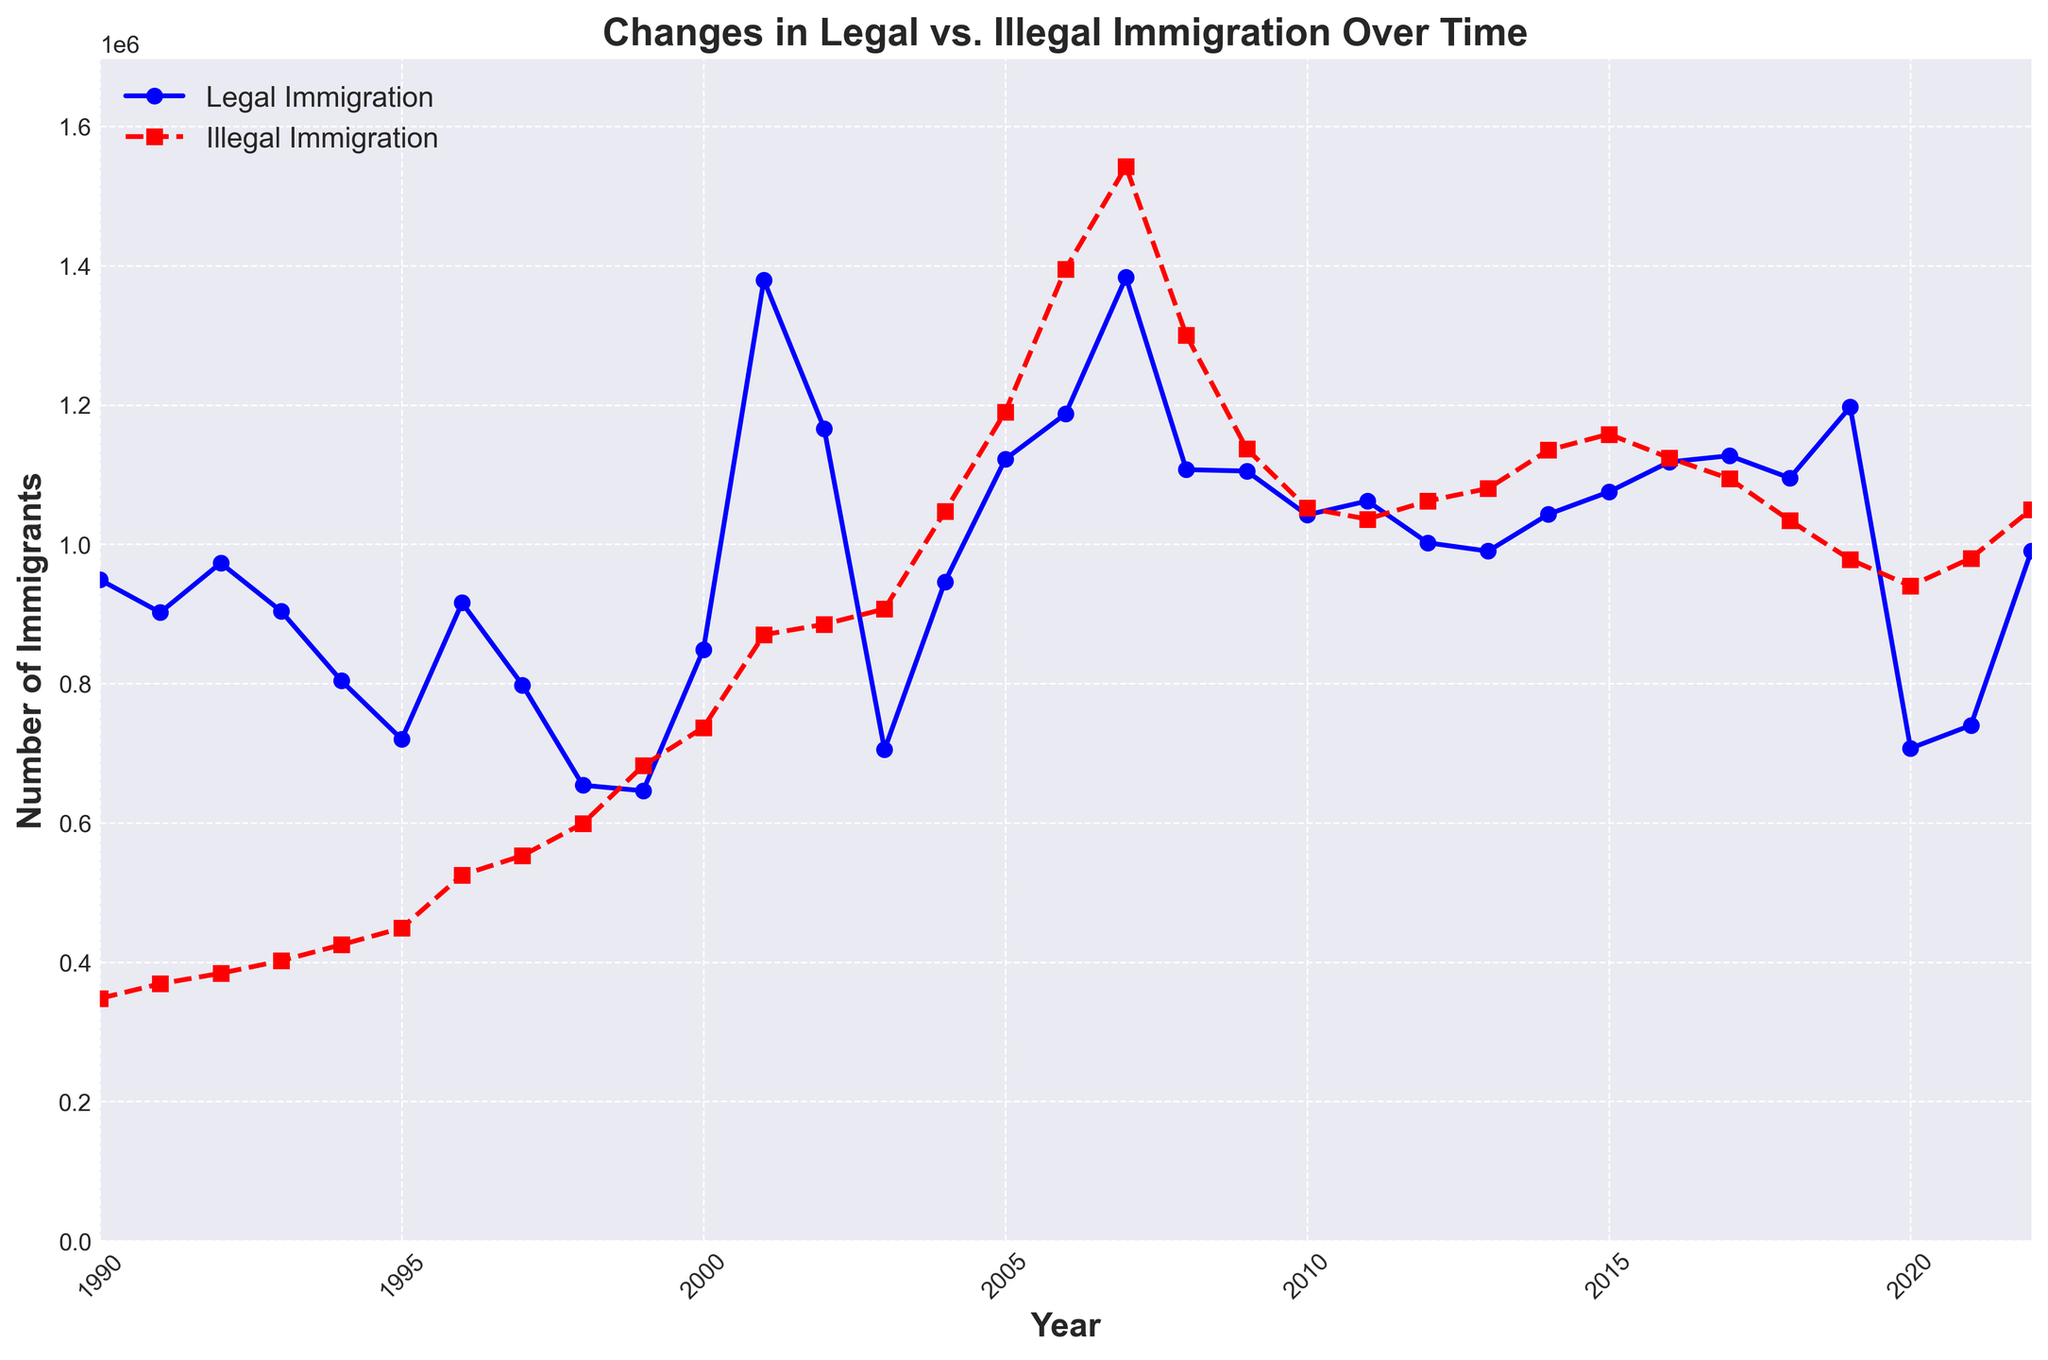What was the highest number of legal immigrants recorded in a single year? To find the highest number of legal immigrants in a single year, look at the 'Legal Immigration' line on the figure and identify the peak point. The peak occurs at 2001 with 1,379,000 immigrants.
Answer: 1,379,000 In which year did illegal immigration first exceed 1,000,000? To determine when illegal immigration first crossed 1,000,000, look for the 'Illegal Immigration' line and check the year where the line first goes above the 1,000,000 mark. This happens in 2004.
Answer: 2004 Between which consecutive years did legal immigration see the biggest drop? Find consecutive years by observing the largest decline in the 'Legal Immigration' line. The biggest drop occurred between 2001 and 2002, decreasing from 1,379,000 to 1,166,000.
Answer: 2001-2002 What is the difference between legal and illegal immigration in the year 2007? Look at the respective values for legal (1,383,000) and illegal (1,542,000) immigration in 2007 and subtract the legal from the illegal immigration figures. The difference is 1,542,000 - 1,383,000 = 159,000.
Answer: 159,000 Which year exhibited the lowest illegal immigration? Identify the year with the minimum point on the 'Illegal Immigration' line. The lowest value is recorded in 1990 with 348,000 illegal immigrants.
Answer: 1990 How does the number of illegal immigrants in 2020 compare to those in 2019? Compare the values directly from the two years. The illegal immigration in 2020 (940,000) is lower than in 2019 (978,000).
Answer: Lower Did any single year report both more legal immigrants than the following year and more illegal immigrants than the following year? Examine the lines to find where both the legal and illegal immigration values in one year are higher than the subsequent year. In 2008, legal immigration (1,107,000) is higher than 2009 (1,105,000), and illegal immigration (1,300,000) is higher than 2009 (1,137,000).
Answer: 2008 What was the trend of illegal immigration from 2007 to 2010? Increase, decrease, or fluctuate? Follow the path of the 'Illegal Immigration' line between 2007 and 2010. Illegal immigration decreases from 1,542,000 in 2007 to 1,052,000 in 2010, indicating a decreasing trend.
Answer: Decrease How many more illegal immigrants were there than legal immigrants in the year 2006? Find the values for both legal (1,187,000) and illegal (1,395,000) immigration in 2006 and subtract legal from illegal immigration. The difference is 1,395,000 - 1,187,000 = 208,000.
Answer: 208,000 What is the average number of legal immigrants between 2018 and 2022? Sum the legal immigration numbers from 2018 to 2022 (1,095,000 + 1,197,000 + 707,000 + 740,000 + 990,000) and divide by 5. The average is (1,095,000 + 1,197,000 + 707,000 + 740,000 + 990,000) / 5 = 945,800.
Answer: 945,800 